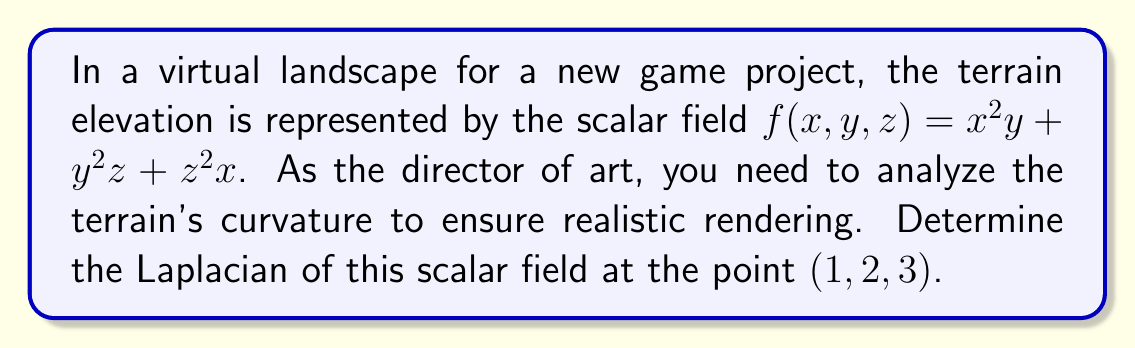Give your solution to this math problem. To find the Laplacian of the scalar field $f(x,y,z) = x^2y + y^2z + z^2x$ at the point $(1,2,3)$, we need to follow these steps:

1) The Laplacian in 3D Cartesian coordinates is given by:

   $$\nabla^2f = \frac{\partial^2f}{\partial x^2} + \frac{\partial^2f}{\partial y^2} + \frac{\partial^2f}{\partial z^2}$$

2) Let's calculate each second partial derivative:

   a) $\frac{\partial f}{\partial x} = 2xy + z^2$
      $\frac{\partial^2f}{\partial x^2} = 2y$

   b) $\frac{\partial f}{\partial y} = x^2 + 2yz$
      $\frac{\partial^2f}{\partial y^2} = 2z$

   c) $\frac{\partial f}{\partial z} = y^2 + 2zx$
      $\frac{\partial^2f}{\partial z^2} = 2x$

3) Now, we sum these second partial derivatives:

   $$\nabla^2f = 2y + 2z + 2x$$

4) Evaluate this at the point $(1,2,3)$:

   $$\nabla^2f(1,2,3) = 2(2) + 2(3) + 2(1) = 4 + 6 + 2 = 12$$

Therefore, the Laplacian of the scalar field at the point $(1,2,3)$ is 12.
Answer: 12 